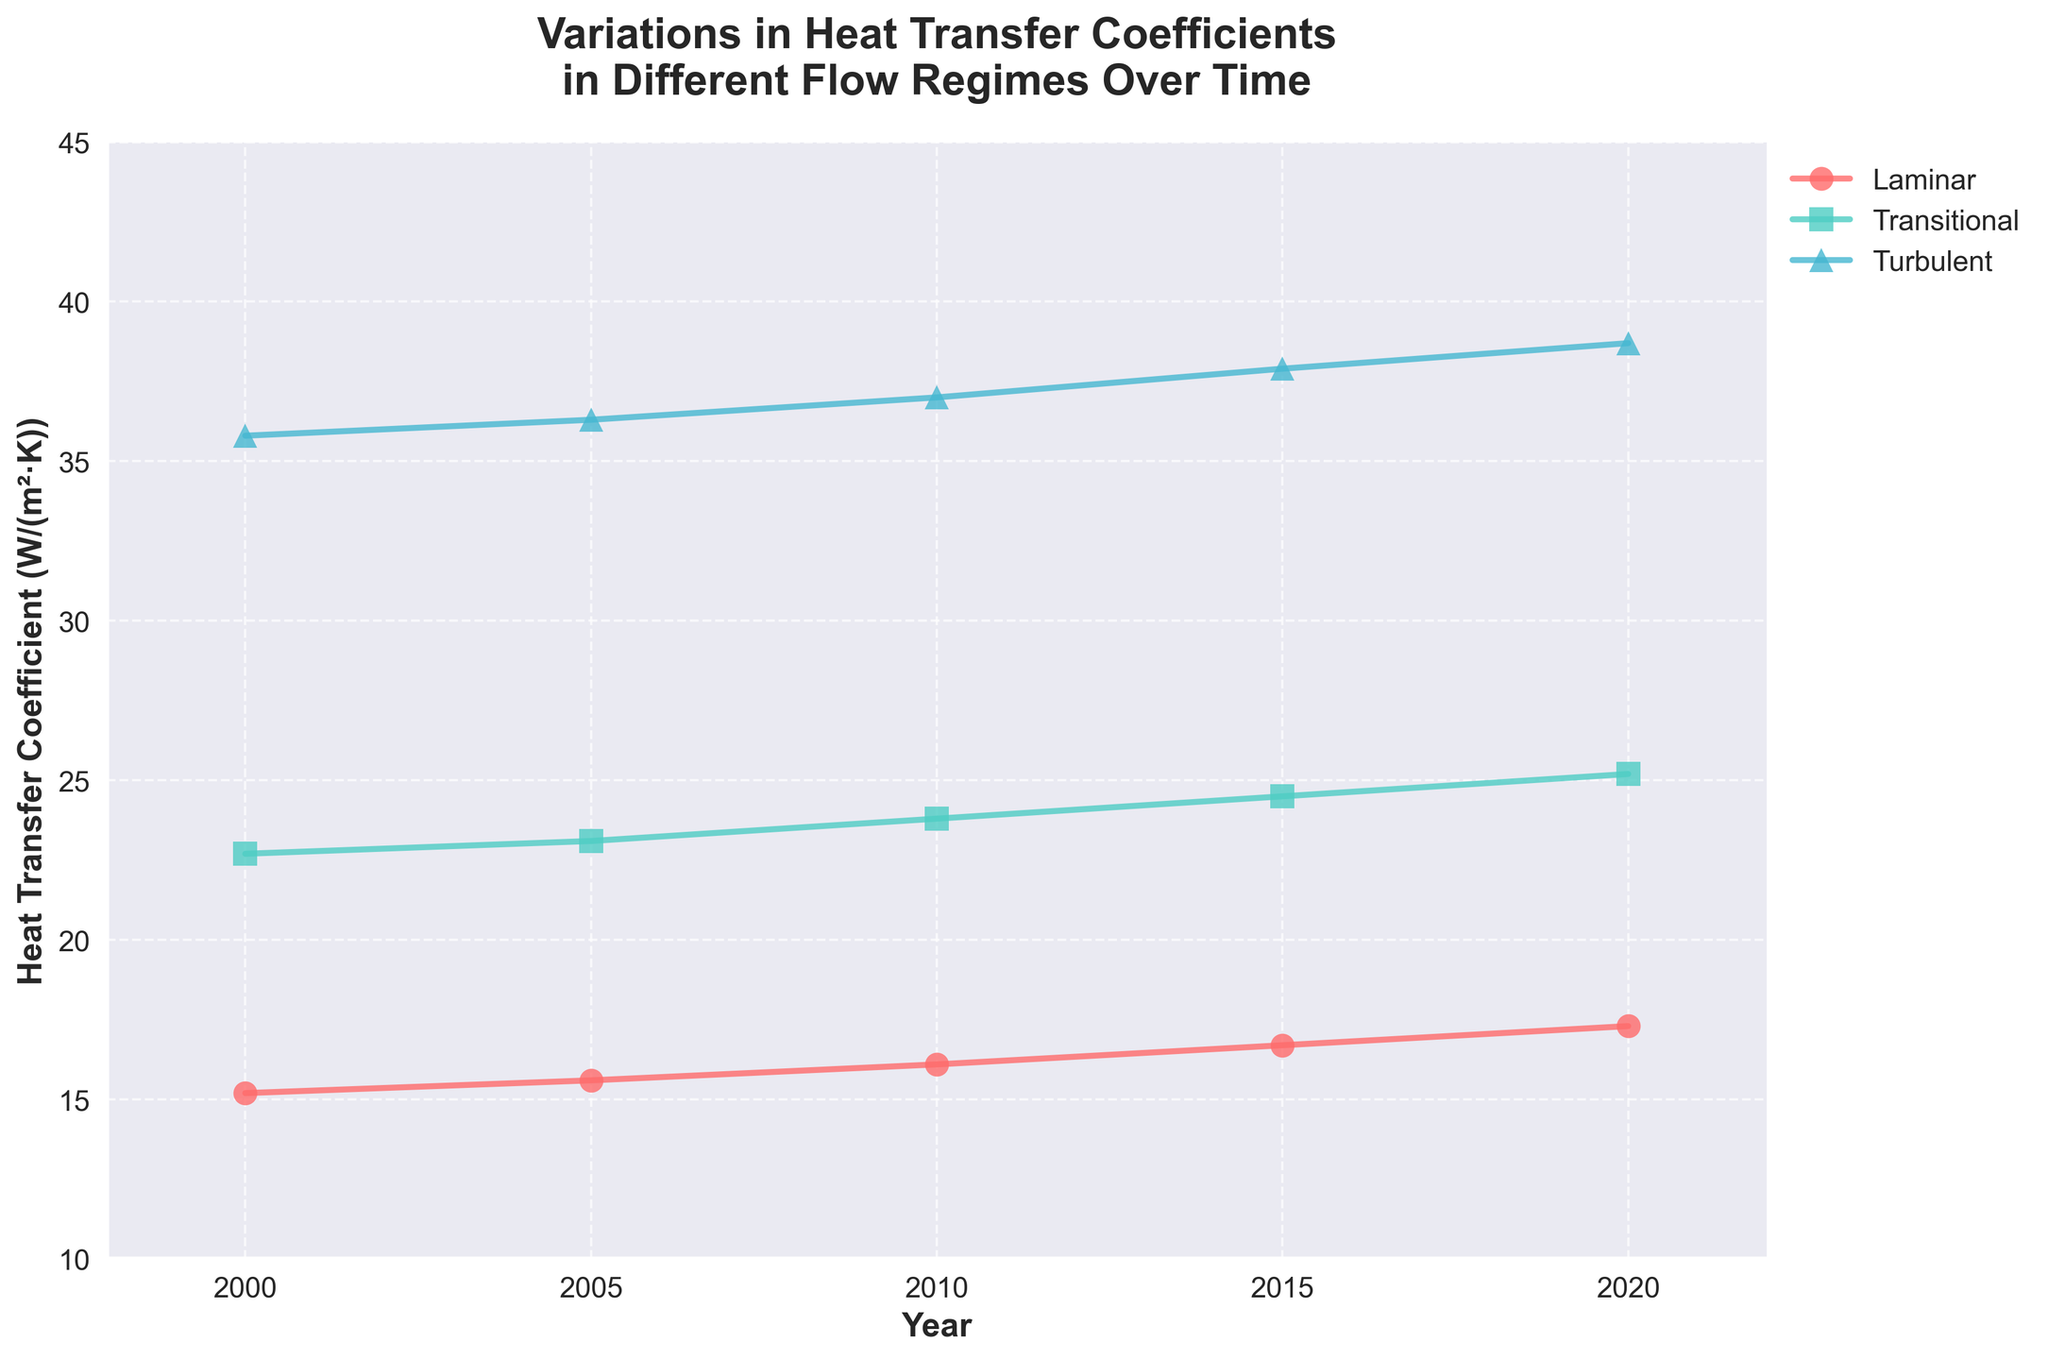How many flow regimes are represented in the time series plot? The figure shows three distinct flow regimes represented by different lines. Each line corresponds to a unique flow regime: Laminar, Transitional, and Turbulent.
Answer: Three What was the trend in the heat transfer coefficient for the Turbulent flow regime over the years? The plot shows that the heat transfer coefficient in the Turbulent flow regime consistently increased from 35.8 W/(m²·K) in 2000 to 38.7 W/(m²·K) in 2020. This indicates a steady upward trend over the observed period.
Answer: Steady increase Which year shows the highest heat transfer coefficient for the Transitional flow regime? To find the highest value for the Transitional flow regime, look at the data points for each year. The highest heat transfer coefficient in the Transitional regime is 25.2 W/(m²·K) in 2020.
Answer: 2020 How does the heat transfer coefficient for the Laminar flow regime in 2005 compare to that in 2020? In the figure, the heat transfer coefficient for the Laminar regime in 2005 is 15.6 W/(m²·K) and in 2020 is 17.3 W/(m²·K). Comparing the two, the coefficient increased from 2005 to 2020.
Answer: It increased What’s the average increase in the heat transfer coefficient for the Laminar regime per year between 2000 and 2020? The heat transfer coefficient for the Laminar regime increased from 15.2 W/(m²·K) in 2000 to 17.3 W/(m²·K) in 2020. The total increase is 17.3 - 15.2 = 2.1 W/(m²·K) over 20 years. The average increase per year is 2.1 / 20 ≈ 0.105 W/(m²·K).
Answer: ~0.105 W/(m²·K) Is there any year where all three flow regimes have the same trend in terms of the direction (increase or decrease) of the heat transfer coefficient compared to the previous year? Observing the trend lines, in every year, all three flow regimes show an increase in the heat transfer coefficient compared to the previous year. There is no year where one regime decreases while others increase.
Answer: Yes, all years show increase Which flow regime shows the greatest variation in heat transfer coefficient across the years? By observing the range of heat transfer coefficients for each flow regime over the years, the Turbulent regime shows the greatest variation, from 35.8 W/(m²·K) in 2000 to 38.7 W/(m²·K) in 2020, a variation of 2.9 W/(m²·K).
Answer: Turbulent Between which consecutive years did the Transitional flow regime experience the largest increase in heat transfer coefficient? The figure shows that the heat transfer coefficient for the Transitional regime increases as follows: 22.7 to 23.1 (2000 to 2005), 23.1 to 23.8 (2005 to 2010), 23.8 to 24.5 (2010 to 2015), and 24.5 to 25.2 (2015 to 2020). The largest increase is from 2015 to 2020, with an increase of 0.7 W/(m²·K).
Answer: 2015 to 2020 